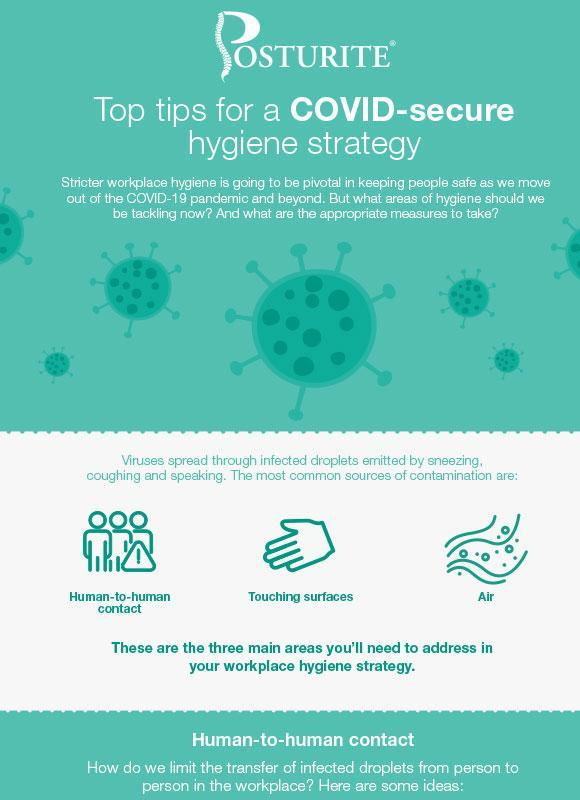What is shown as the second source by which the disease can spread?
Answer the question with a short phrase. Touching surfaces How many common sources of contamination are shown in the infographic? 3 